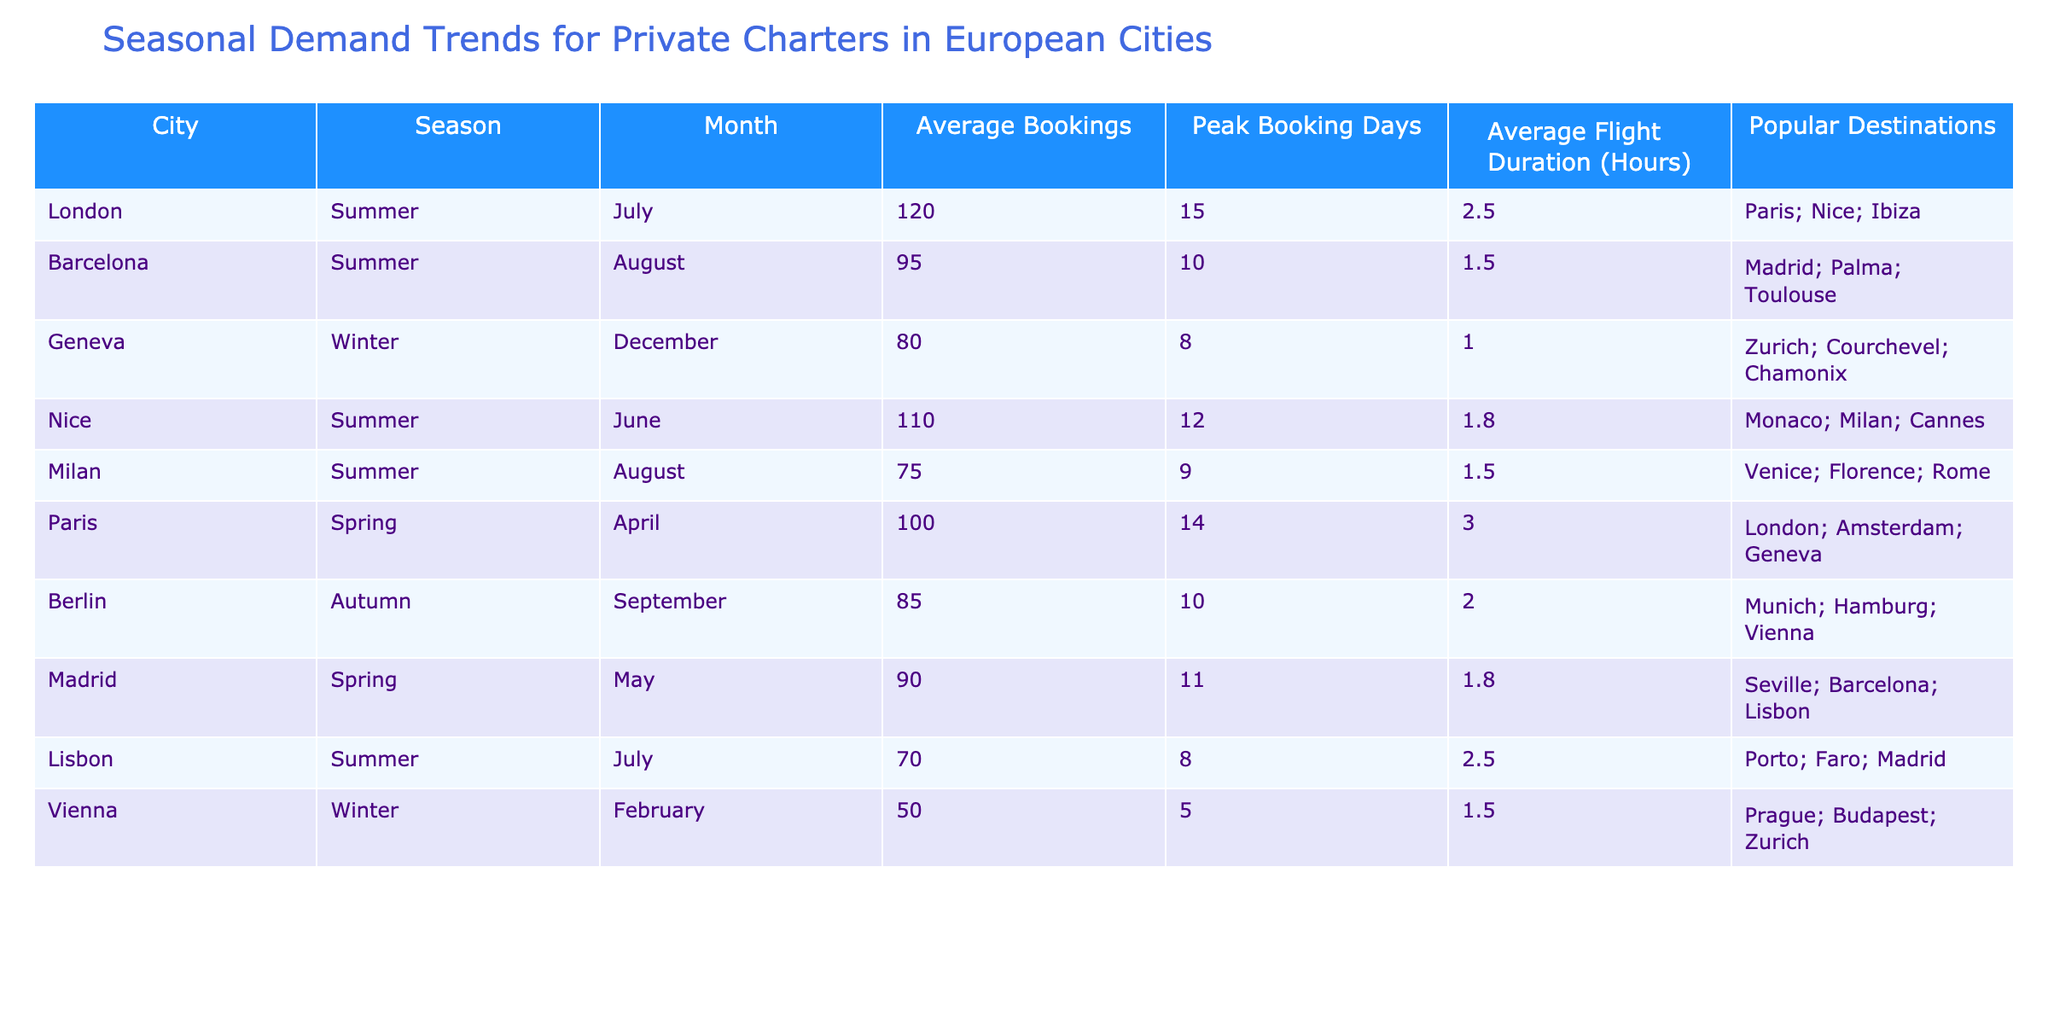What city has the highest average bookings in summer? By examining the table, we can see that London has an average of 120 bookings in July, which is the highest among all the cities listed during the summer season.
Answer: London How many peak booking days does Vienna have in winter? The table indicates that Vienna has 5 peak booking days in February, which is the only winter month listed in the data.
Answer: 5 What is the average flight duration for private charters in Paris during spring? In the table, it shows that the average flight duration for Paris in April is 3.0 hours. Thus, this is the average flight duration during the spring season.
Answer: 3.0 hours What is the total average bookings for summer across all cities listed? The summer average bookings can be calculated by adding the average bookings for London (120), Barcelona (95), Nice (110), Milan (75), and Lisbon (70). Summing these gives 120 + 95 + 110 + 75 + 70 = 470. Thus, the total average bookings for summer is 470.
Answer: 470 Does Nice have more peak booking days than Madrid in spring? According to the table, Nice has 12 peak booking days in June, whereas Madrid has 11 peak booking days in May. Thus, Nice does indeed have more peak booking days than Madrid in spring.
Answer: Yes Which city has the lowest average bookings and what season does it correspond to? The table shows that Vienna has the lowest average bookings with 50 during the winter season (February). This indicates that winter is the season corresponding to the lowest bookings.
Answer: Vienna, Winter What are the popular destinations for summer flights from London? The table lists the popular destinations for London during summer as Paris, Nice, and Ibiza. These destinations are highly sought after during this season.
Answer: Paris; Nice; Ibiza How many hours is the average flight duration for private charters in summer compared to winter? In summer, the average flight duration is calculated by considering London (2.5), Barcelona (1.5), Nice (1.8), Milan (1.5), and Lisbon (2.5). The average for summer is (2.5 + 1.5 + 1.8 + 1.5 + 2.5) / 5 = 1.78 hours. For winter, we have Geneva (1.0) and Vienna (1.5), giving an average of (1.0 + 1.5) / 2 = 1.25 hours. Therefore, private charters in summer have a longer average flight duration than in winter by 1.78 - 1.25 = 0.53 hours.
Answer: 0.53 hours longer in summer 